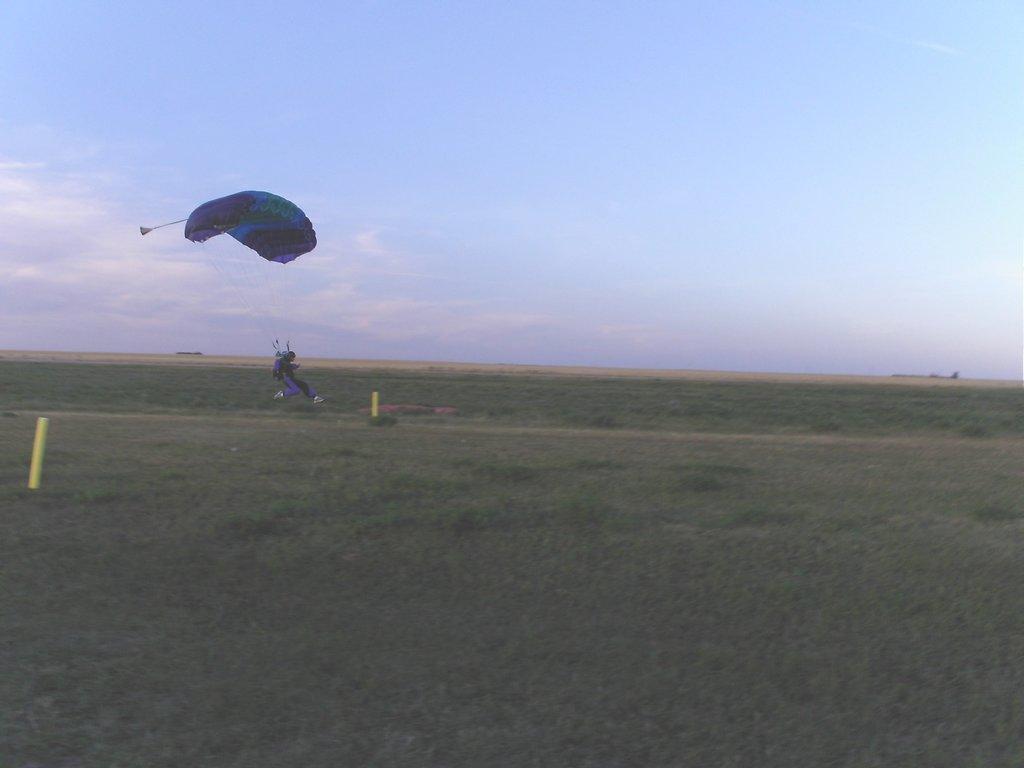Describe this image in one or two sentences. In the image there is a person landing on the ground with a parachute, there are two yellow poles on the ground. 